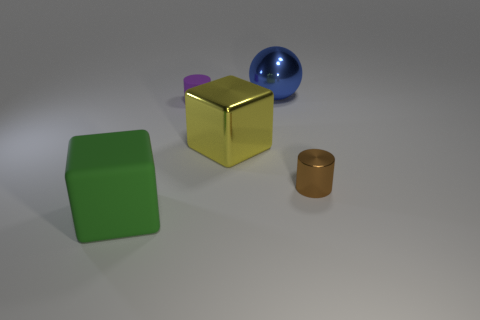Add 3 big blue rubber balls. How many objects exist? 8 Subtract all gray cylinders. Subtract all brown cubes. How many cylinders are left? 2 Subtract all tiny yellow cylinders. Subtract all blue metal things. How many objects are left? 4 Add 1 cubes. How many cubes are left? 3 Add 4 tiny red metallic spheres. How many tiny red metallic spheres exist? 4 Subtract 0 gray cylinders. How many objects are left? 5 Subtract all balls. How many objects are left? 4 